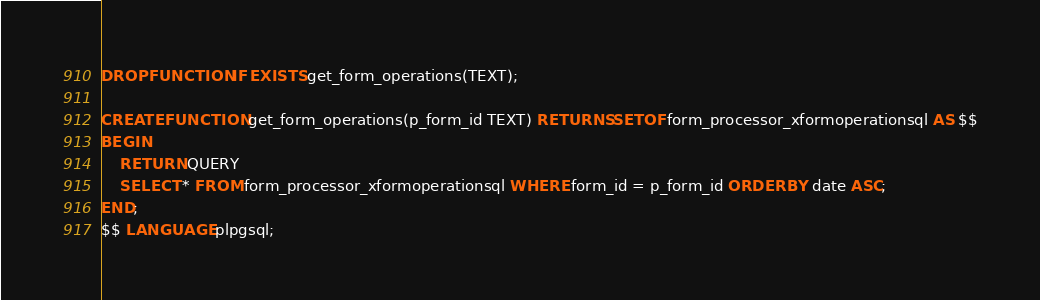<code> <loc_0><loc_0><loc_500><loc_500><_SQL_>DROP FUNCTION IF EXISTS get_form_operations(TEXT);

CREATE FUNCTION get_form_operations(p_form_id TEXT) RETURNS SETOF form_processor_xformoperationsql AS $$
BEGIN
    RETURN QUERY
    SELECT * FROM form_processor_xformoperationsql WHERE form_id = p_form_id ORDER BY date ASC;
END;
$$ LANGUAGE plpgsql;
</code> 